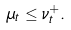<formula> <loc_0><loc_0><loc_500><loc_500>\mu _ { t } \leq \nu _ { t } ^ { + } .</formula> 